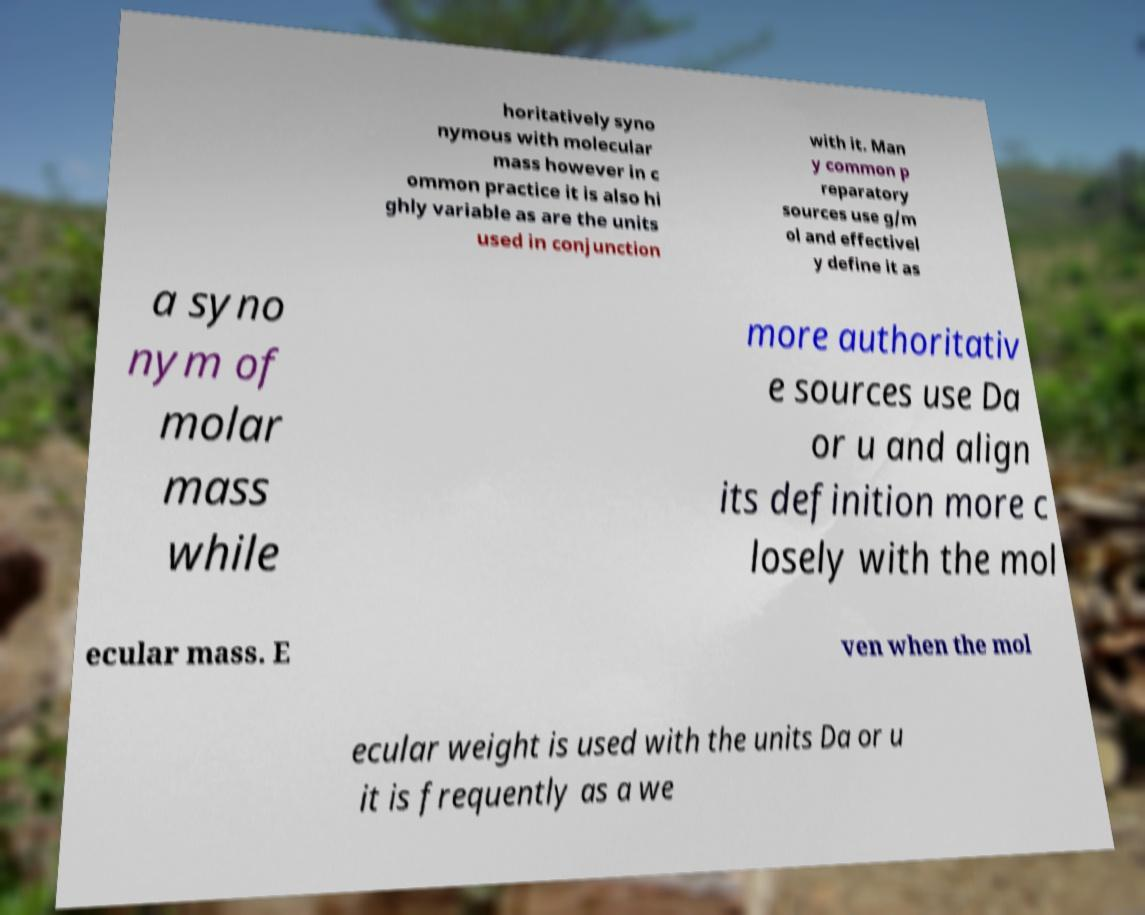I need the written content from this picture converted into text. Can you do that? horitatively syno nymous with molecular mass however in c ommon practice it is also hi ghly variable as are the units used in conjunction with it. Man y common p reparatory sources use g/m ol and effectivel y define it as a syno nym of molar mass while more authoritativ e sources use Da or u and align its definition more c losely with the mol ecular mass. E ven when the mol ecular weight is used with the units Da or u it is frequently as a we 